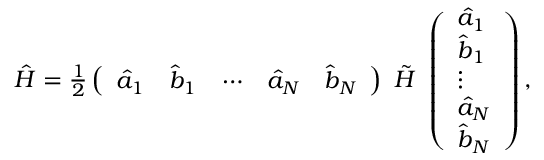<formula> <loc_0><loc_0><loc_500><loc_500>\begin{array} { r } { \hat { H } = \frac { 1 } { 2 } \left ( \begin{array} { l l l l l } { \hat { a } _ { 1 } } & { \hat { b } _ { 1 } } & { \cdots } & { \hat { a } _ { N } } & { \hat { b } _ { N } } \end{array} \right ) \tilde { H } \left ( \begin{array} { l } { \hat { a } _ { 1 } } \\ { \hat { b } _ { 1 } } \\ { \vdots } \\ { \hat { a } _ { N } } \\ { \hat { b } _ { N } } \end{array} \right ) , } \end{array}</formula> 